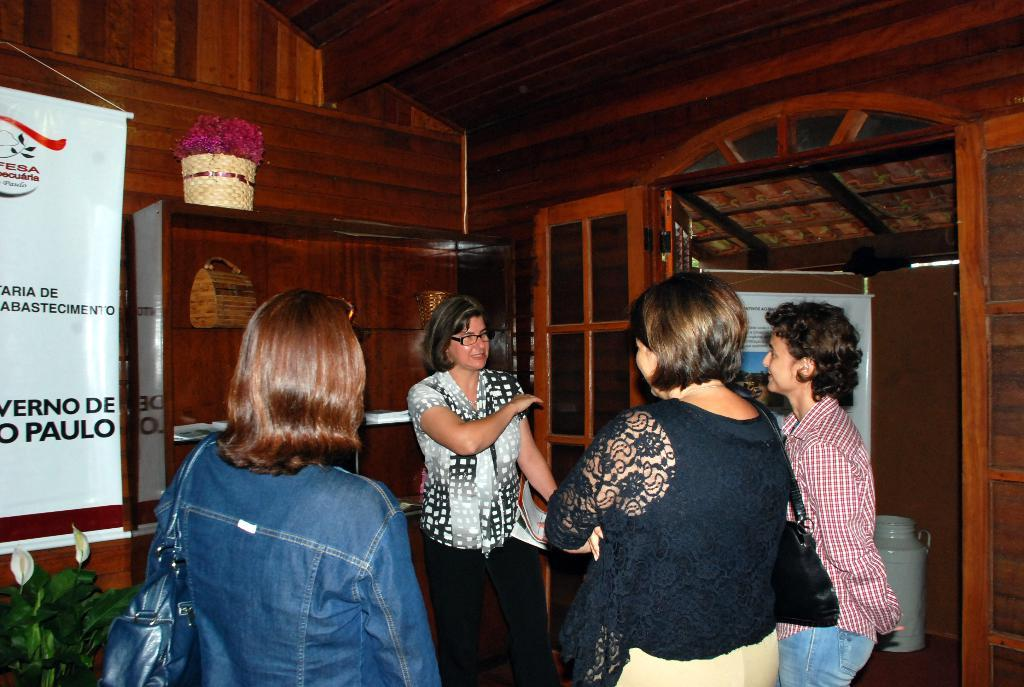What are the women in the image doing? The women in the image are standing and talking. Where are the women located? The women are in a room. Can you describe any other objects or features in the room? There is a plant in the bottom left corner of the image. What type of bomb is visible in the image? There is no bomb present in the image. What kind of quilt is being used as a backdrop for the women in the image? There is no quilt present in the image. 